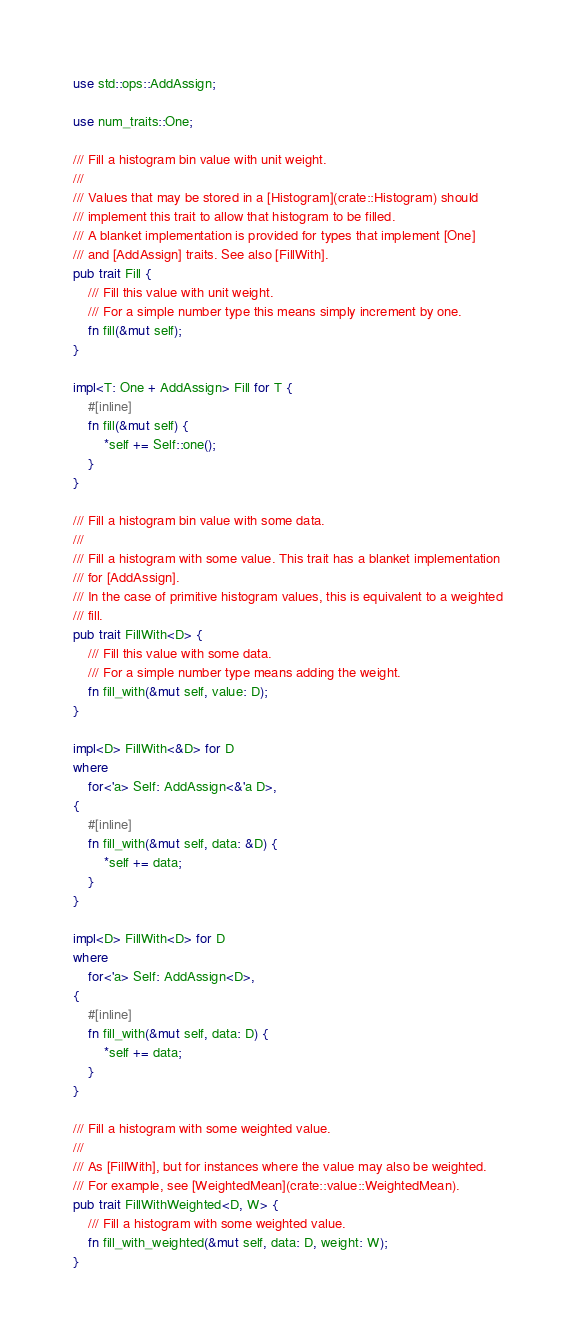<code> <loc_0><loc_0><loc_500><loc_500><_Rust_>use std::ops::AddAssign;

use num_traits::One;

/// Fill a histogram bin value with unit weight.
///
/// Values that may be stored in a [Histogram](crate::Histogram) should
/// implement this trait to allow that histogram to be filled.
/// A blanket implementation is provided for types that implement [One]
/// and [AddAssign] traits. See also [FillWith].
pub trait Fill {
    /// Fill this value with unit weight.
    /// For a simple number type this means simply increment by one.
    fn fill(&mut self);
}

impl<T: One + AddAssign> Fill for T {
    #[inline]
    fn fill(&mut self) {
        *self += Self::one();
    }
}

/// Fill a histogram bin value with some data.
///
/// Fill a histogram with some value. This trait has a blanket implementation
/// for [AddAssign].
/// In the case of primitive histogram values, this is equivalent to a weighted
/// fill.
pub trait FillWith<D> {
    /// Fill this value with some data.
    /// For a simple number type means adding the weight.
    fn fill_with(&mut self, value: D);
}

impl<D> FillWith<&D> for D
where
    for<'a> Self: AddAssign<&'a D>,
{
    #[inline]
    fn fill_with(&mut self, data: &D) {
        *self += data;
    }
}

impl<D> FillWith<D> for D
where
    for<'a> Self: AddAssign<D>,
{
    #[inline]
    fn fill_with(&mut self, data: D) {
        *self += data;
    }
}

/// Fill a histogram with some weighted value.
///
/// As [FillWith], but for instances where the value may also be weighted.
/// For example, see [WeightedMean](crate::value::WeightedMean).
pub trait FillWithWeighted<D, W> {
    /// Fill a histogram with some weighted value.
    fn fill_with_weighted(&mut self, data: D, weight: W);
}
</code> 